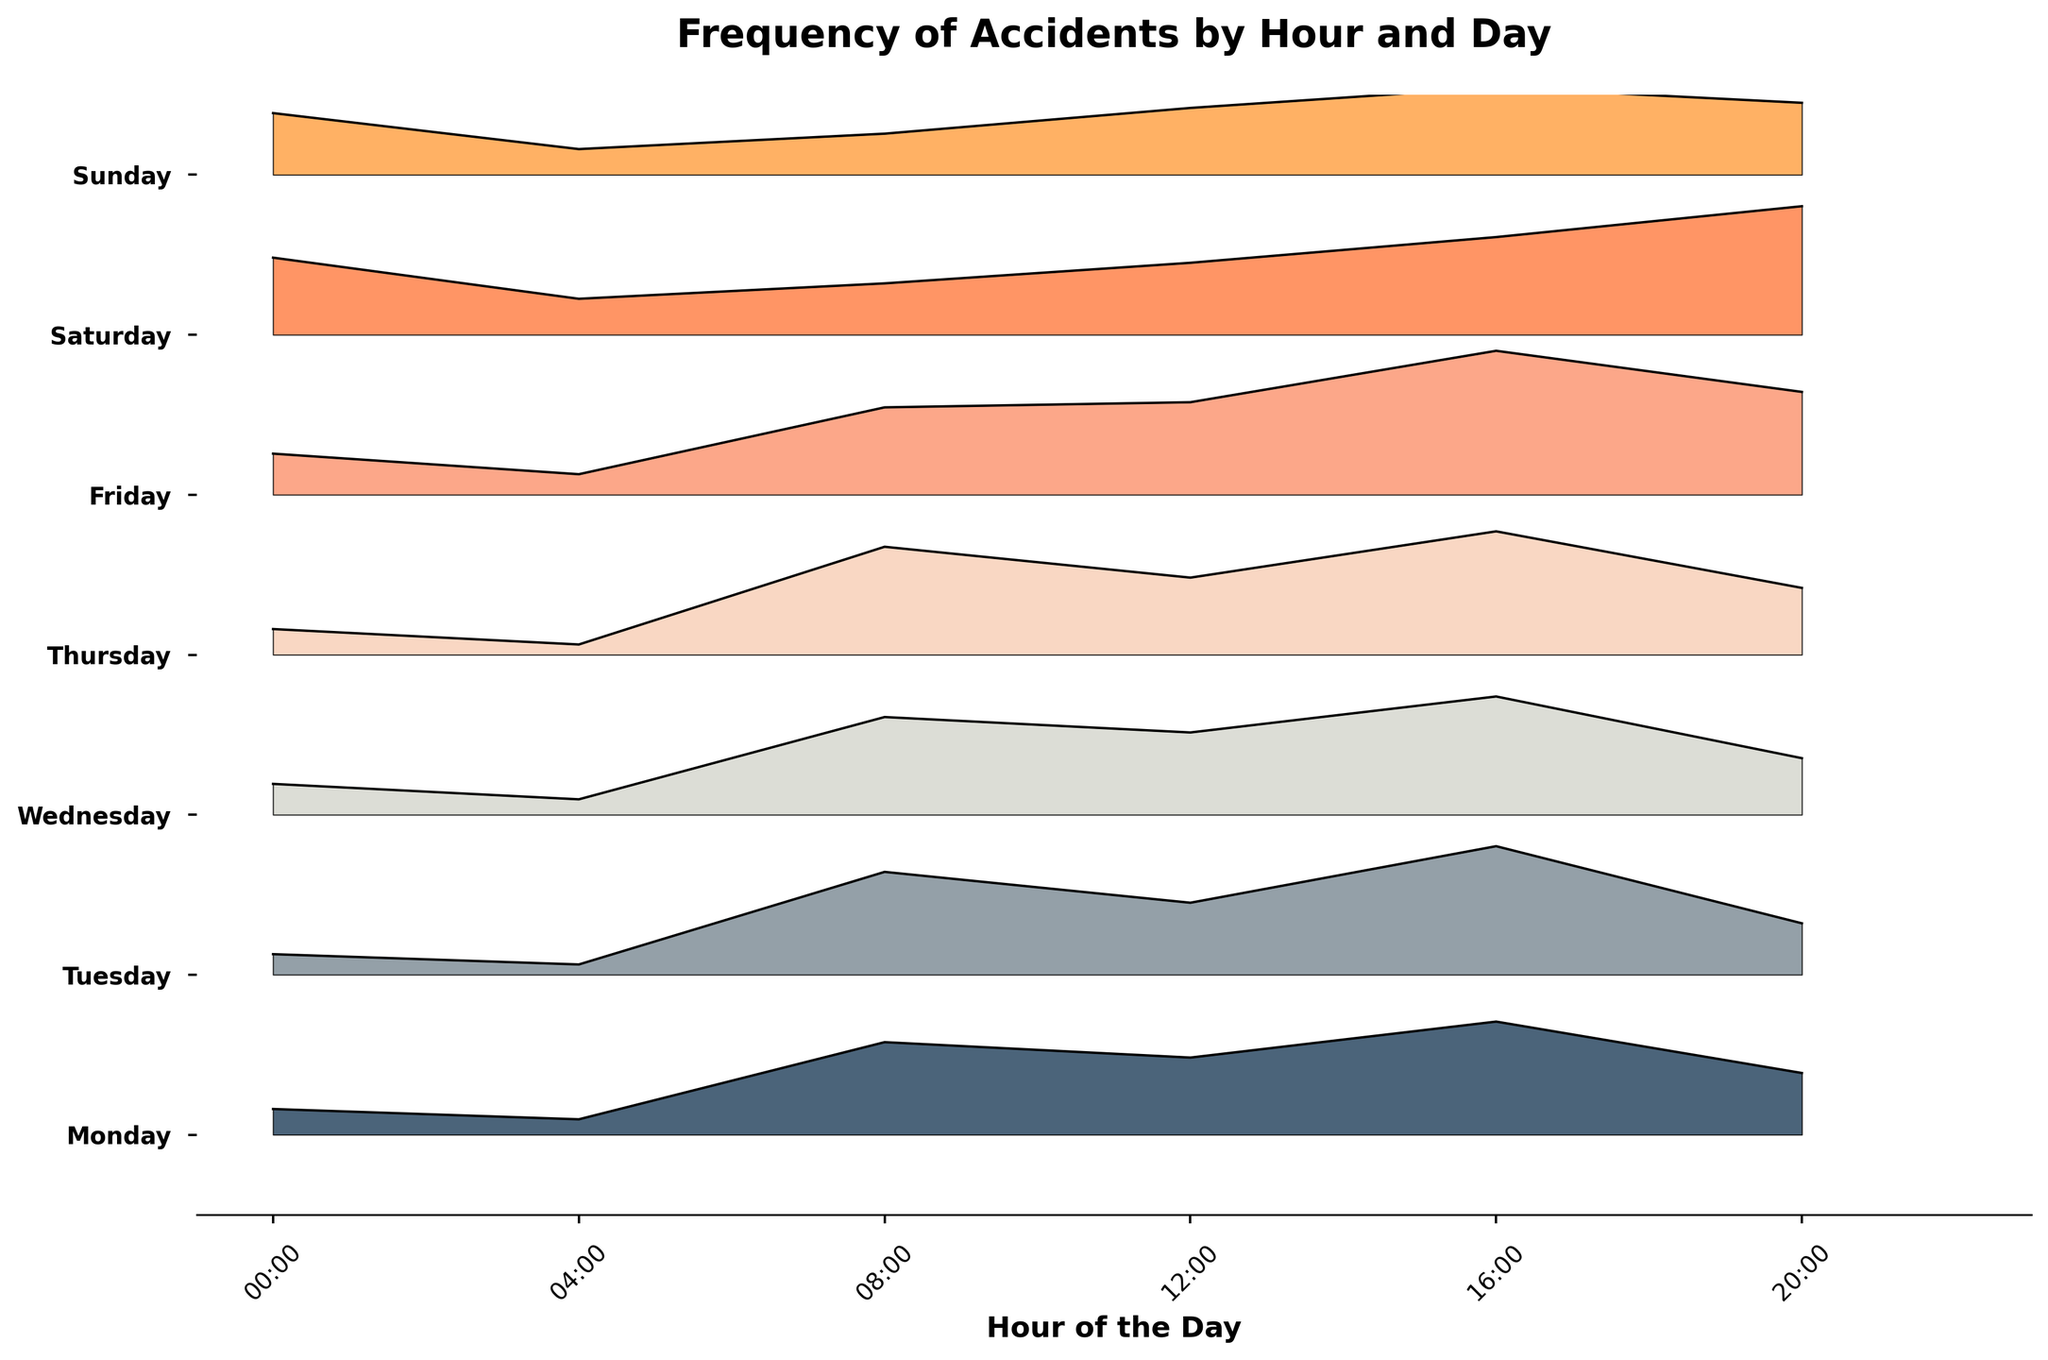What is the title of the figure? The title of the figure is displayed at the top and is meant to give a clear indication of what the graph represents. It reads "Frequency of Accidents by Hour and Day".
Answer: Frequency of Accidents by Hour and Day Which day shows the highest frequency of accidents at 16:00? To answer this, look at the peaks of the ridgelines at 16:00 for each day. The highest peak at this time corresponds to Friday.
Answer: Friday What is the average frequency of accidents at 8:00 across all days? To find the average, sum the frequencies of accidents at 8:00 for each day, then divide by 7 (number of days). The frequencies are 18, 20, 19, 21, 17, 10, and 8. Sum these to get 113, and then divide 113 by 7.
Answer: 16.14 On which day do accidents at midnight (00:00) occur most frequently? Check the ridgeline points at 00:00 for each day. The highest point at midnight is for Saturday.
Answer: Saturday How does the frequency of accidents at 20:00 on Sunday compare to the frequency at 20:00 on Saturday? Compare the peaks at 20:00 for both Sunday and Saturday. Sunday has a frequency of 14, while Saturday has a frequency of 25.
Answer: Saturday has more accidents at 20:00 Which day has the lowest frequency of accidents at 4:00? Examine the ridgeline points at 4:00 for each day. The day with the lowest peak at this hour is Tuesday and Thursday, both with a frequency of 2.
Answer: Tuesday or Thursday Are there more accidents at noon (12:00) on Monday or on Friday? Compare the ridgeline points at 12:00 for Monday and Friday. Monday has a frequency of 15, while Friday has a frequency of 18.
Answer: Friday What time shows the highest frequency of accidents on Wednesday? Look at the highest peak on the Wednesday ridgeline. The highest frequency is at 16:00, with a count of 23.
Answer: 16:00 What is the total frequency of accidents at 16:00 across all days? Sum the frequencies at 16:00 for each day. The frequencies are 22 (Monday), 25 (Tuesday), 23 (Wednesday), 24 (Thursday), 28 (Friday), 19 (Saturday), and 17 (Sunday). Summing these values gives 158.
Answer: 158 